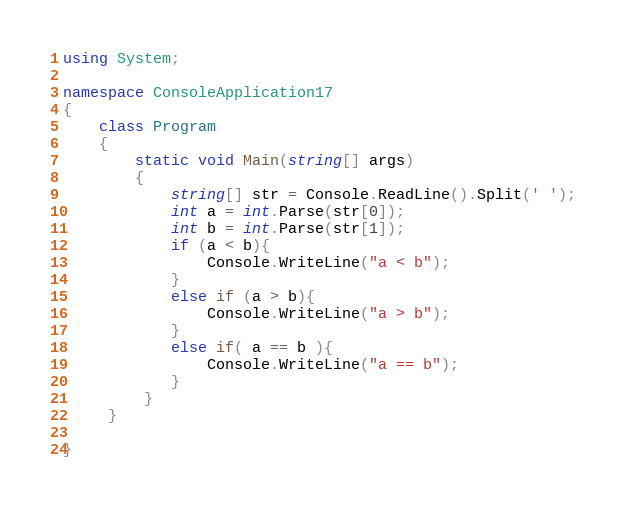Convert code to text. <code><loc_0><loc_0><loc_500><loc_500><_C#_>using System;

namespace ConsoleApplication17
{
    class Program
    {
        static void Main(string[] args)
        {
            string[] str = Console.ReadLine().Split(' ');
            int a = int.Parse(str[0]);
            int b = int.Parse(str[1]);
            if (a < b){
                Console.WriteLine("a < b");
            }
            else if (a > b){
                Console.WriteLine("a > b");
            }
            else if( a == b ){
                Console.WriteLine("a == b");
            }
         }
     }
    
}</code> 